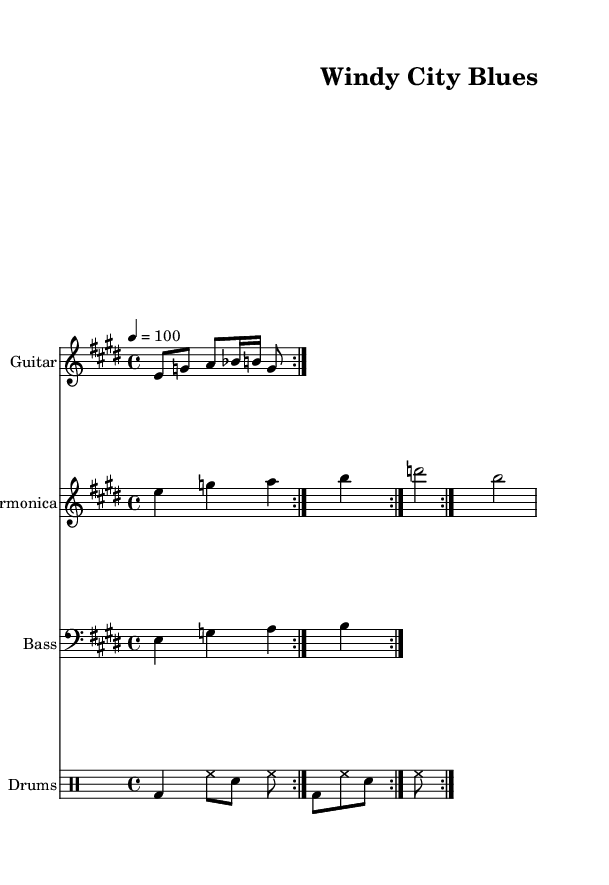What is the key signature of this music? The key signature is indicated by the number of sharps or flats placed at the beginning of the staff. In this sheet music, the key signature shows four sharps, which corresponds to E major.
Answer: E major What is the time signature of this piece? The time signature is shown at the beginning of the staff, indicating how many beats are contained in each measure. In this sheet music, the time signature is 4/4, meaning there are four beats per measure and the quarter note represents one beat.
Answer: 4/4 What is the tempo marking for this music? The tempo marking is found in the header information and indicates the speed of the piece. The marking in this sheet music specifies a tempo of "4 = 100," meaning there are 100 beats per minute.
Answer: 100 How many measures does the guitar riff repeat? The guitar riff is marked with a volta directive that indicates how many times it should be played. In this sheet music, it has a repeat mark that shows it repeats two times.
Answer: 2 What instrument plays the melody alongside the guitar? The sheet music includes multiple staves for different instruments. The staff labeled "Harmonica" displays the melody that complements the guitar riff, indicating that this instrument plays alongside the guitar.
Answer: Harmonica What drumming elements are included in the drum pattern? The drum pattern consists of various notations which indicate different sounds produced by the drums. In this case, the pattern includes bass drum (bd), hi-hat (hh), and snare (sn), showing a standard structure for a blues rhythm.
Answer: Bass drum, hi-hat, snare Which section of the music carries the bass line? The bass line is indicated in the section labeled "Bass," which is set on its own staff. This staff is distinct from the others and utilizes a bass clef, confirming that it contains the bass line for the piece.
Answer: Bass 